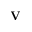Convert formula to latex. <formula><loc_0><loc_0><loc_500><loc_500>V</formula> 